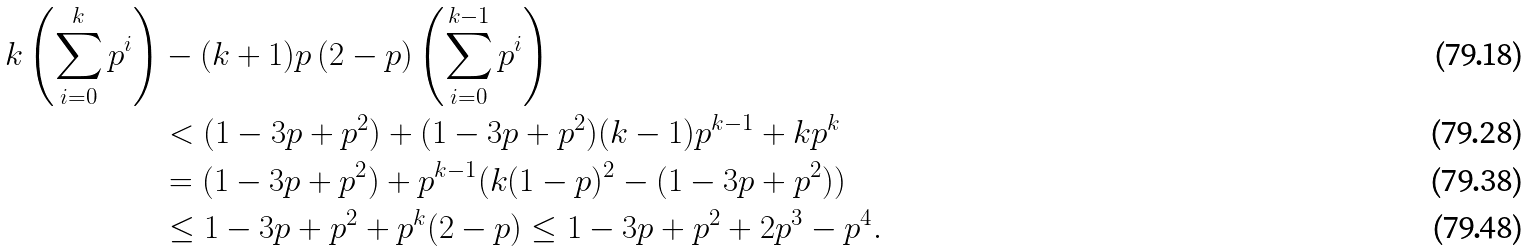Convert formula to latex. <formula><loc_0><loc_0><loc_500><loc_500>k \left ( \sum _ { i = 0 } ^ { k } p ^ { i } \right ) & - ( k + 1 ) p \, ( 2 - p ) \left ( \sum _ { i = 0 } ^ { k - 1 } p ^ { i } \right ) \\ & < ( 1 - 3 p + p ^ { 2 } ) + ( 1 - 3 p + p ^ { 2 } ) ( k - 1 ) p ^ { k - 1 } + k p ^ { k } \\ & = ( 1 - 3 p + p ^ { 2 } ) + p ^ { k - 1 } ( k ( 1 - p ) ^ { 2 } - ( 1 - 3 p + p ^ { 2 } ) ) \\ & \leq 1 - 3 p + p ^ { 2 } + p ^ { k } ( 2 - p ) \leq 1 - 3 p + p ^ { 2 } + 2 p ^ { 3 } - p ^ { 4 } .</formula> 